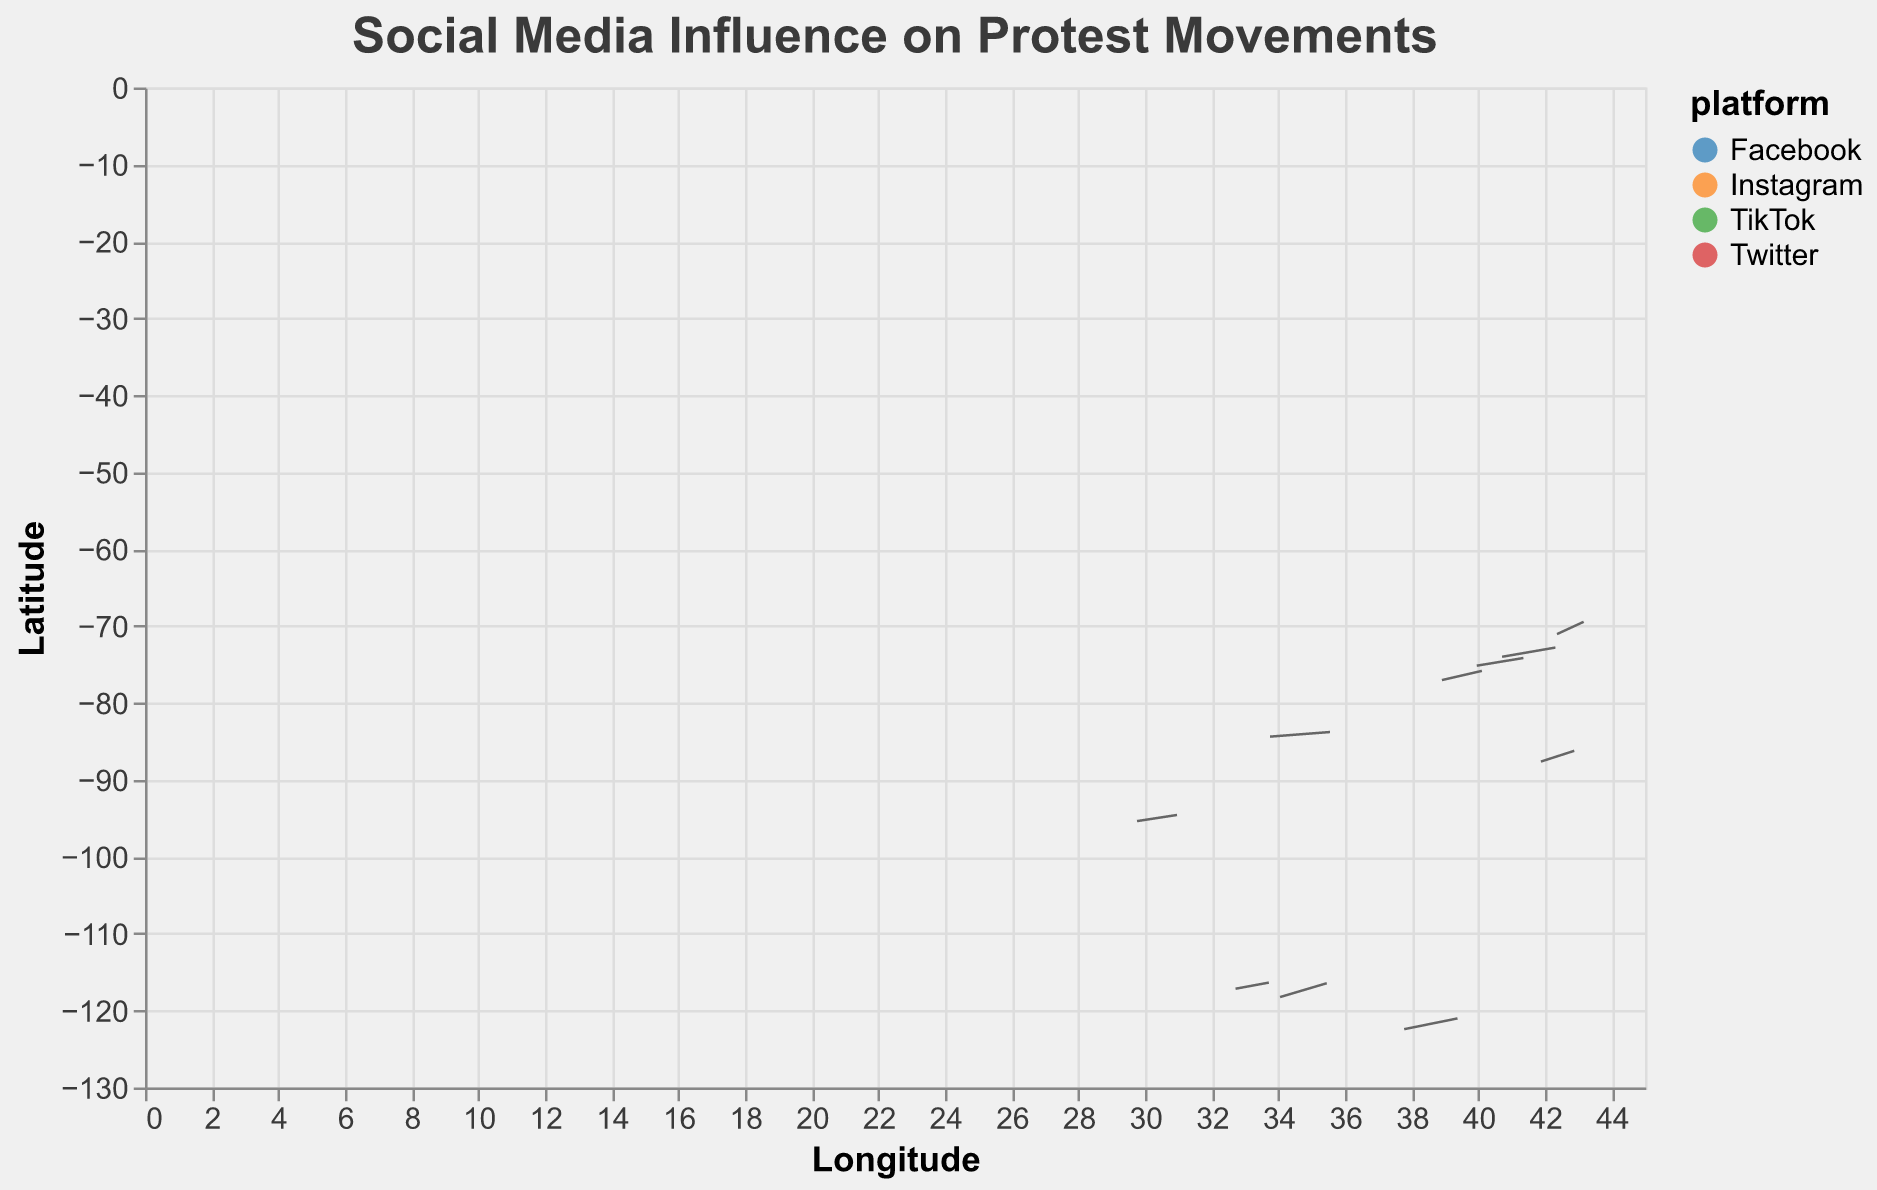What's the title of the figure? The title of the figure is displayed prominently at the top.
Answer: Social Media Influence on Protest Movements What information is represented on the x-axis and y-axis? The x-axis represents Longitude, and the y-axis represents Latitude.
Answer: Longitude and Latitude Which city has the highest magnitude of influence? By analyzing the sizes of the points, the largest point corresponds to New York City.
Answer: New York City Which platform is most influential in Boston? Inspecting the tooltip or color legend associated with Boston, we see the platform is Instagram.
Answer: Instagram How do the magnitude values compare between New York City and San Francisco? New York City has a magnitude of 5000, and San Francisco has 2100. Therefore, New York City's magnitude is more than double San Francisco's.
Answer: New York City has more than double the influence of San Francisco Which city uses TikTok and has the second-lowest magnitude of influence? By identifying which cities are associated with TikTok and comparing their magnitudes, San Diego has the second-lowest magnitude (1900).
Answer: San Diego Which cities have a dominant influence from Twitter, and how does their direction of influence (u and v) compare? Two cities are influenced by Twitter: New York City (u=0.8, v=0.6) and Atlanta (u=0.9, v=0.3). Both have strong u directions, but New York City also has a significant v component, while Atlanta's v component is smaller.
Answer: New York City and Atlanta What's the average influence magnitude for Instagram in the cities listed? Instagram has influencers in Los Angeles (4200), Boston (2700), and San Francisco (2100). Summing these gives 9000, and the average is 9000/3.
Answer: 3000 In which direction does the influence point in Los Angeles? The influence direction is given by the vector components (u=0.7, v=0.9), which implies a strong movement both east and slightly north.
Answer: East and slightly north 